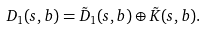Convert formula to latex. <formula><loc_0><loc_0><loc_500><loc_500>D _ { 1 } ( s , b ) = \tilde { D } _ { 1 } ( s , b ) \oplus \tilde { K } ( s , b ) .</formula> 